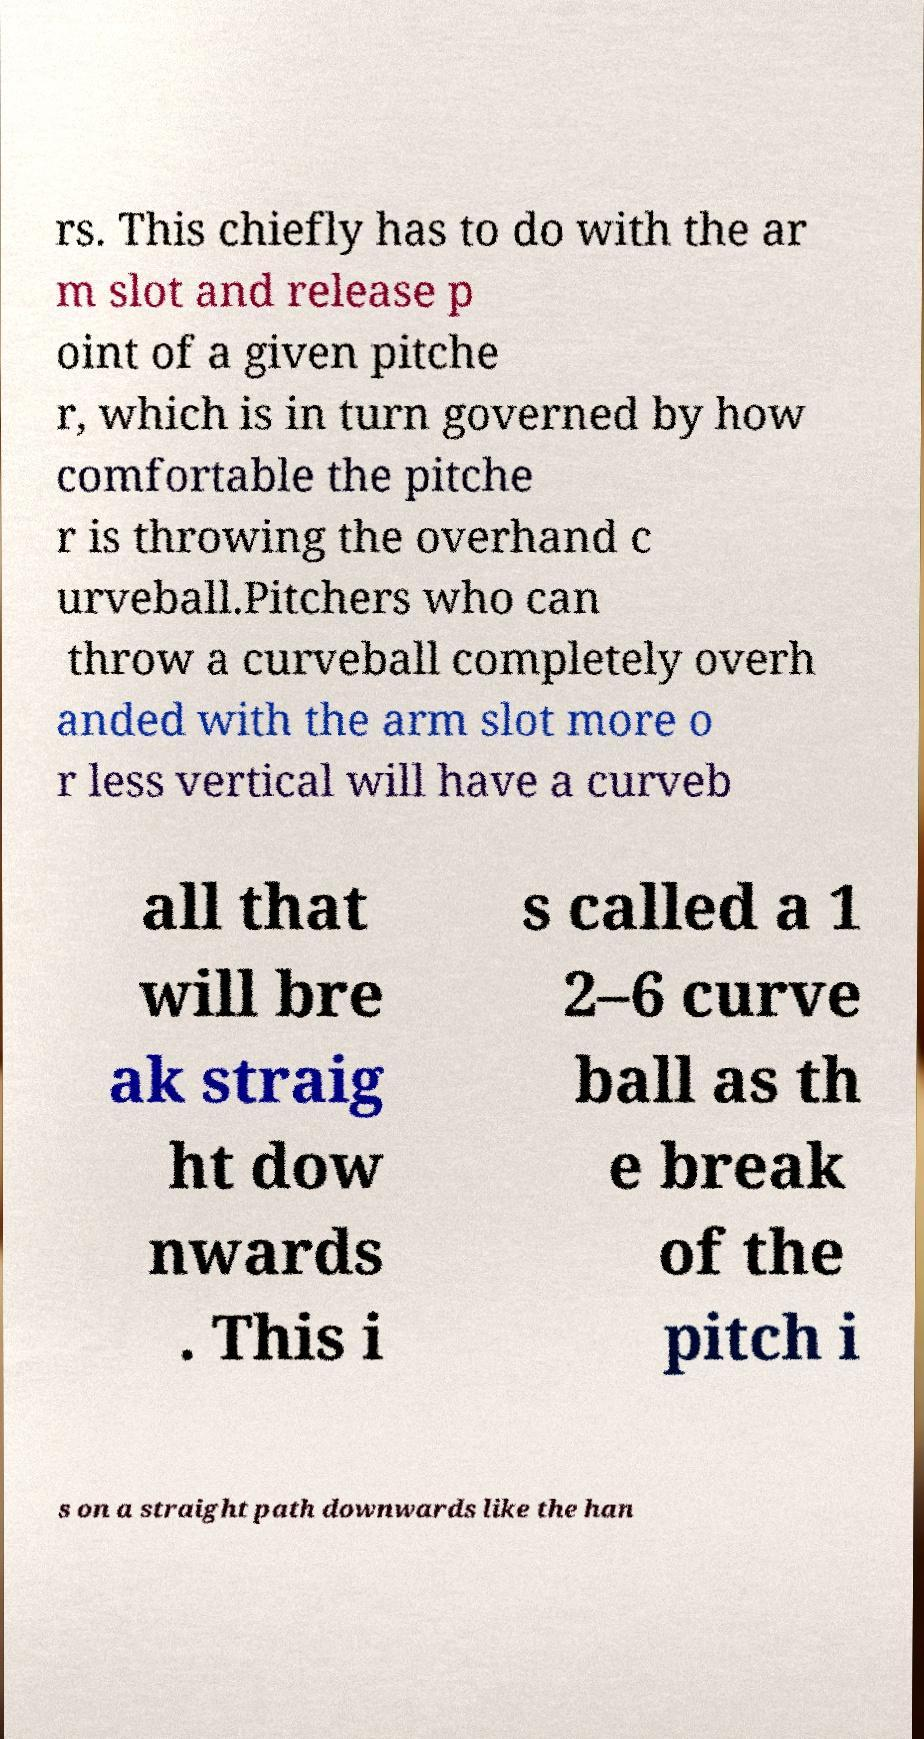Can you accurately transcribe the text from the provided image for me? rs. This chiefly has to do with the ar m slot and release p oint of a given pitche r, which is in turn governed by how comfortable the pitche r is throwing the overhand c urveball.Pitchers who can throw a curveball completely overh anded with the arm slot more o r less vertical will have a curveb all that will bre ak straig ht dow nwards . This i s called a 1 2–6 curve ball as th e break of the pitch i s on a straight path downwards like the han 